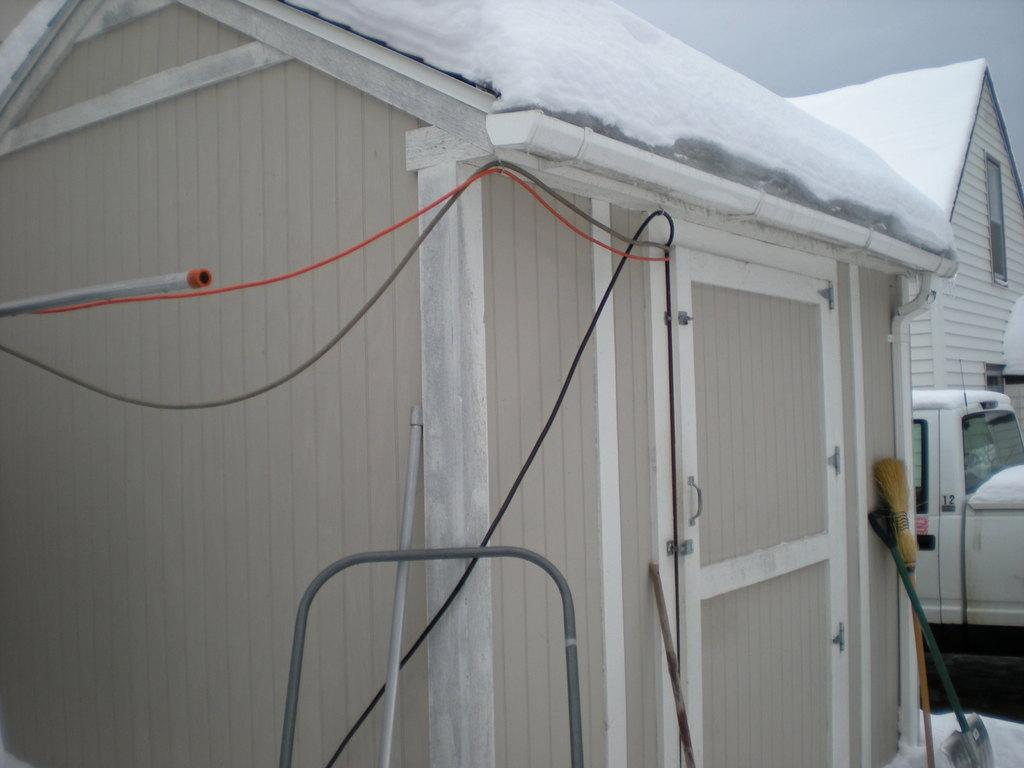What type of structures can be seen in the image? There are houses in the image. What else is present in the image besides the houses? There are wires and vehicles visible in the image. What type of fiction is being read by the houses in the image? There is no indication in the image that the houses are reading any fiction. What process is being used by the vehicles to move in the image? The image does not show any specific process being used by the vehicles to move; it only shows that they are present. 